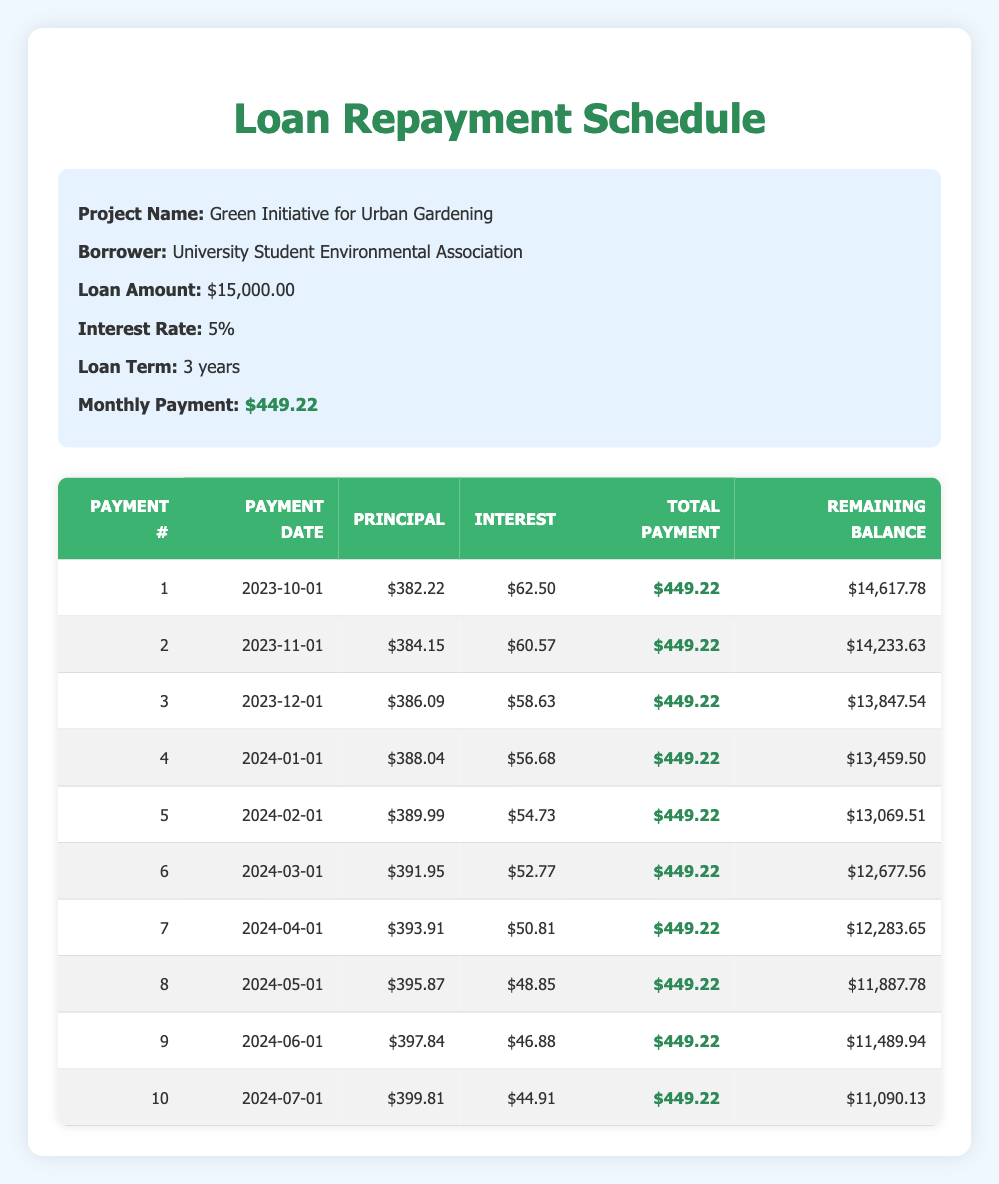What is the total loan amount for the Green Initiative for Urban Gardening project? The loan amount is directly stated in the table under loan details, which shows 15,000.00.
Answer: 15000.00 How much is the monthly payment planned for the loan? The monthly payment is located in the loan details section, listed as 449.22.
Answer: 449.22 What was the remaining balance after the first payment? The remaining balance is recorded in the first row of the repayment plan, showing 14,617.78 after the first payment.
Answer: 14617.78 Is the interest payment in the second month less than the interest payment in the first month? The second month's interest payment is 60.57 while the first month's is 62.50. Since 60.57 is less than 62.50, the statement is true.
Answer: Yes What is the total principal paid after the first three payments? To calculate the total principal paid, add the principal payments from the first three payments: 382.22 + 384.15 + 386.09 = 1152.46.
Answer: 1152.46 What is the average monthly interest payment for the first three payments? To find the average monthly interest payment, add the interest payments for the first three payments (62.50 + 60.57 + 58.63) = 181.70, then divide by 3, giving 181.70 / 3 ≈ 60.57.
Answer: 60.57 What was the principal payment in the fifth month? The principal payment for the fifth month is explicitly listed in the repayment plan as 389.99.
Answer: 389.99 Is the total payment for every month consistent throughout the loan term? The total payment for each month is consistently listed as 449.22 across all the payment entries, indicating they are indeed the same.
Answer: Yes What is the difference in remaining balance between the fourth payment and the second payment? The remaining balance after the fourth payment is 13,459.50 and after the second is 14,233.63. The difference is calculated as 14,233.63 - 13,459.50 = 774.13.
Answer: 774.13 What is the decrease in the interest payment from the first payment to the last payment listed in this table? The interest payment for the first payment is 62.50, and for the last payment, it is 44.91. The decrease is calculated as 62.50 - 44.91 = 17.59.
Answer: 17.59 